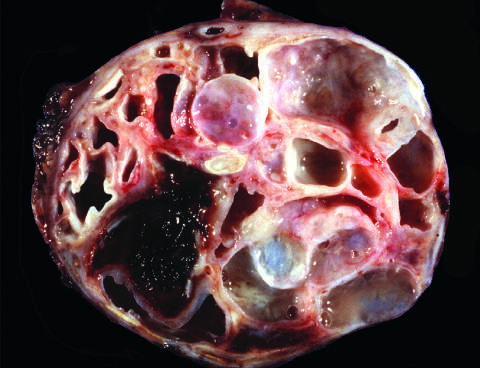what are large and filled with tenacious mucin?
Answer the question using a single word or phrase. The cysts 